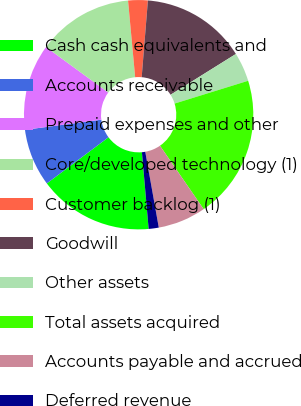<chart> <loc_0><loc_0><loc_500><loc_500><pie_chart><fcel>Cash cash equivalents and<fcel>Accounts receivable<fcel>Prepaid expenses and other<fcel>Core/developed technology (1)<fcel>Customer backlog (1)<fcel>Goodwill<fcel>Other assets<fcel>Total assets acquired<fcel>Accounts payable and accrued<fcel>Deferred revenue<nl><fcel>16.16%<fcel>8.12%<fcel>12.14%<fcel>13.48%<fcel>2.76%<fcel>14.82%<fcel>4.1%<fcel>20.18%<fcel>6.78%<fcel>1.42%<nl></chart> 